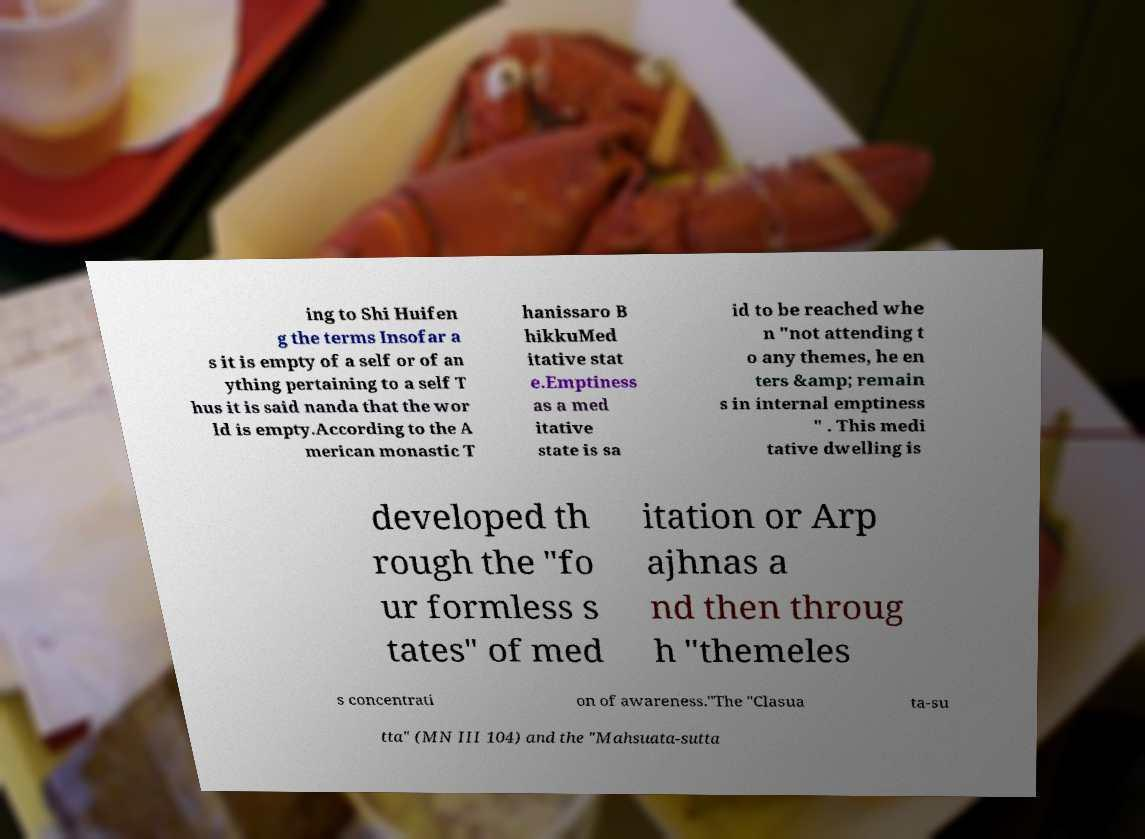There's text embedded in this image that I need extracted. Can you transcribe it verbatim? ing to Shi Huifen g the terms Insofar a s it is empty of a self or of an ything pertaining to a self T hus it is said nanda that the wor ld is empty.According to the A merican monastic T hanissaro B hikkuMed itative stat e.Emptiness as a med itative state is sa id to be reached whe n "not attending t o any themes, he en ters &amp; remain s in internal emptiness " . This medi tative dwelling is developed th rough the "fo ur formless s tates" of med itation or Arp ajhnas a nd then throug h "themeles s concentrati on of awareness."The "Clasua ta-su tta" (MN III 104) and the "Mahsuata-sutta 